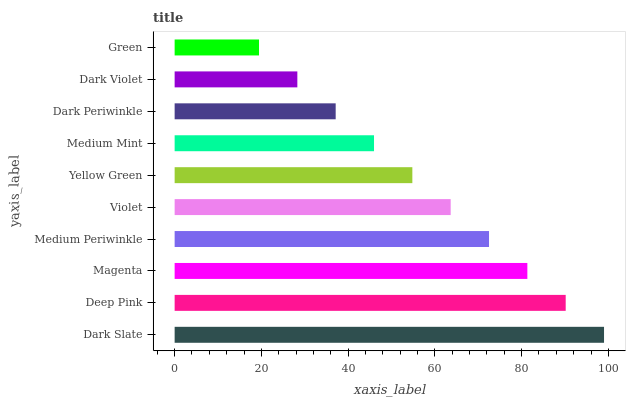Is Green the minimum?
Answer yes or no. Yes. Is Dark Slate the maximum?
Answer yes or no. Yes. Is Deep Pink the minimum?
Answer yes or no. No. Is Deep Pink the maximum?
Answer yes or no. No. Is Dark Slate greater than Deep Pink?
Answer yes or no. Yes. Is Deep Pink less than Dark Slate?
Answer yes or no. Yes. Is Deep Pink greater than Dark Slate?
Answer yes or no. No. Is Dark Slate less than Deep Pink?
Answer yes or no. No. Is Violet the high median?
Answer yes or no. Yes. Is Yellow Green the low median?
Answer yes or no. Yes. Is Dark Violet the high median?
Answer yes or no. No. Is Deep Pink the low median?
Answer yes or no. No. 